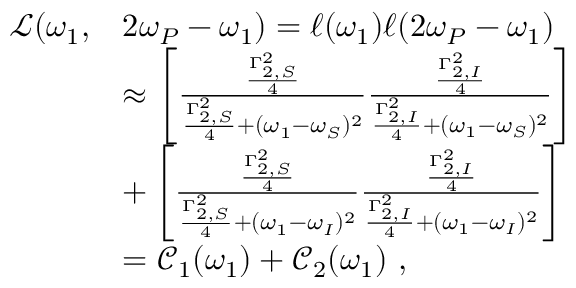Convert formula to latex. <formula><loc_0><loc_0><loc_500><loc_500>\begin{array} { r l } { \mathcal { L } ( \omega _ { 1 } , } & { 2 \omega _ { P } - \omega _ { 1 } ) = \ell ( \omega _ { 1 } ) \ell ( 2 \omega _ { P } - \omega _ { 1 } ) } \\ & { \approx \left [ \frac { \frac { \Gamma _ { 2 , S } ^ { 2 } } { 4 } } { \frac { \Gamma _ { 2 , S } ^ { 2 } } { 4 } + ( \omega _ { 1 } - \omega _ { S } ) ^ { 2 } } \frac { \frac { \Gamma _ { 2 , I } ^ { 2 } } { 4 } } { \frac { \Gamma _ { 2 , I } ^ { 2 } } { 4 } + ( \omega _ { 1 } - \omega _ { S } ) ^ { 2 } } \right ] } \\ & { + \left [ \frac { \frac { \Gamma _ { 2 , S } ^ { 2 } } { 4 } } { \frac { \Gamma _ { 2 , S } ^ { 2 } } { 4 } + ( \omega _ { 1 } - \omega _ { I } ) ^ { 2 } } \frac { \frac { \Gamma _ { 2 , I } ^ { 2 } } { 4 } } { \frac { \Gamma _ { 2 , I } ^ { 2 } } { 4 } + ( \omega _ { 1 } - \omega _ { I } ) ^ { 2 } } \right ] } \\ & { = \mathcal { C } _ { 1 } ( \omega _ { 1 } ) + \mathcal { C } _ { 2 } ( \omega _ { 1 } ) \ , } \end{array}</formula> 